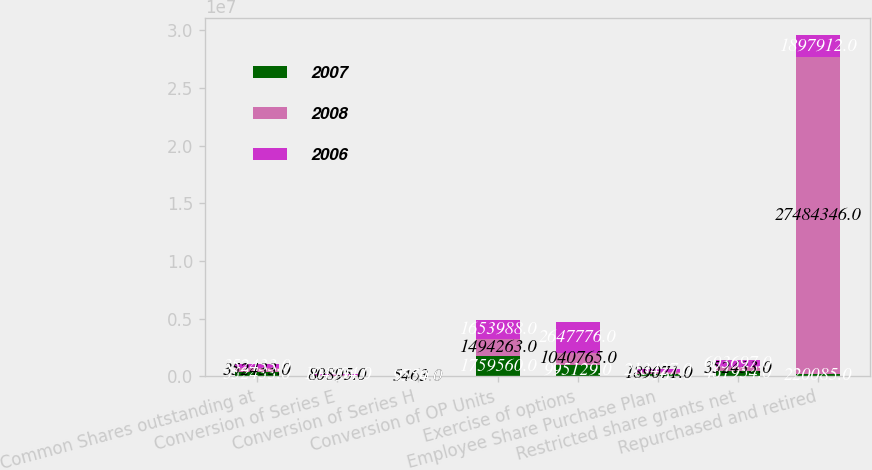Convert chart to OTSL. <chart><loc_0><loc_0><loc_500><loc_500><stacked_bar_chart><ecel><fcel>Common Shares outstanding at<fcel>Conversion of Series E<fcel>Conversion of Series H<fcel>Conversion of OP Units<fcel>Exercise of options<fcel>Employee Share Purchase Plan<fcel>Restricted share grants net<fcel>Repurchased and retired<nl><fcel>2007<fcel>352433<fcel>36830<fcel>2750<fcel>1.75956e+06<fcel>995129<fcel>195961<fcel>461954<fcel>220085<nl><fcel>2008<fcel>352433<fcel>80895<fcel>5463<fcel>1.49426e+06<fcel>1.04076e+06<fcel>189071<fcel>352433<fcel>2.74843e+07<nl><fcel>2006<fcel>352433<fcel>104904<fcel>9554<fcel>1.65399e+06<fcel>2.64778e+06<fcel>213427<fcel>603697<fcel>1.89791e+06<nl></chart> 